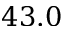<formula> <loc_0><loc_0><loc_500><loc_500>4 3 . 0</formula> 